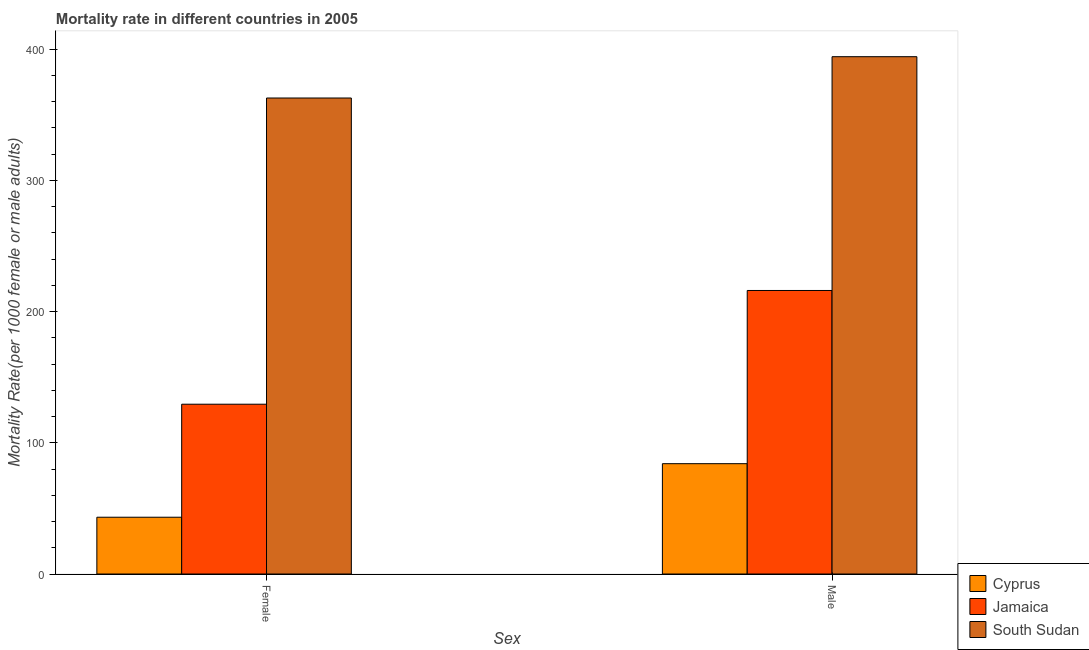How many different coloured bars are there?
Your answer should be compact. 3. How many groups of bars are there?
Provide a short and direct response. 2. Are the number of bars per tick equal to the number of legend labels?
Offer a very short reply. Yes. What is the female mortality rate in Cyprus?
Provide a short and direct response. 43.28. Across all countries, what is the maximum female mortality rate?
Your answer should be compact. 362.8. Across all countries, what is the minimum female mortality rate?
Offer a terse response. 43.28. In which country was the male mortality rate maximum?
Your response must be concise. South Sudan. In which country was the male mortality rate minimum?
Make the answer very short. Cyprus. What is the total male mortality rate in the graph?
Ensure brevity in your answer.  694.47. What is the difference between the female mortality rate in Cyprus and that in South Sudan?
Provide a short and direct response. -319.52. What is the difference between the female mortality rate in Jamaica and the male mortality rate in South Sudan?
Give a very brief answer. -264.87. What is the average female mortality rate per country?
Your response must be concise. 178.5. What is the difference between the male mortality rate and female mortality rate in Jamaica?
Your answer should be very brief. 86.68. What is the ratio of the female mortality rate in Jamaica to that in South Sudan?
Provide a short and direct response. 0.36. Is the female mortality rate in Cyprus less than that in South Sudan?
Offer a terse response. Yes. In how many countries, is the male mortality rate greater than the average male mortality rate taken over all countries?
Offer a terse response. 1. What does the 3rd bar from the left in Male represents?
Provide a short and direct response. South Sudan. What does the 2nd bar from the right in Male represents?
Your response must be concise. Jamaica. How many countries are there in the graph?
Ensure brevity in your answer.  3. What is the difference between two consecutive major ticks on the Y-axis?
Make the answer very short. 100. Does the graph contain any zero values?
Your answer should be very brief. No. Where does the legend appear in the graph?
Offer a terse response. Bottom right. How many legend labels are there?
Your answer should be compact. 3. How are the legend labels stacked?
Keep it short and to the point. Vertical. What is the title of the graph?
Your answer should be very brief. Mortality rate in different countries in 2005. Does "Guyana" appear as one of the legend labels in the graph?
Provide a succinct answer. No. What is the label or title of the X-axis?
Make the answer very short. Sex. What is the label or title of the Y-axis?
Your answer should be very brief. Mortality Rate(per 1000 female or male adults). What is the Mortality Rate(per 1000 female or male adults) in Cyprus in Female?
Keep it short and to the point. 43.28. What is the Mortality Rate(per 1000 female or male adults) in Jamaica in Female?
Provide a succinct answer. 129.42. What is the Mortality Rate(per 1000 female or male adults) of South Sudan in Female?
Give a very brief answer. 362.8. What is the Mortality Rate(per 1000 female or male adults) in Cyprus in Male?
Offer a very short reply. 84.09. What is the Mortality Rate(per 1000 female or male adults) of Jamaica in Male?
Make the answer very short. 216.09. What is the Mortality Rate(per 1000 female or male adults) of South Sudan in Male?
Provide a short and direct response. 394.29. Across all Sex, what is the maximum Mortality Rate(per 1000 female or male adults) of Cyprus?
Ensure brevity in your answer.  84.09. Across all Sex, what is the maximum Mortality Rate(per 1000 female or male adults) of Jamaica?
Your response must be concise. 216.09. Across all Sex, what is the maximum Mortality Rate(per 1000 female or male adults) of South Sudan?
Keep it short and to the point. 394.29. Across all Sex, what is the minimum Mortality Rate(per 1000 female or male adults) of Cyprus?
Ensure brevity in your answer.  43.28. Across all Sex, what is the minimum Mortality Rate(per 1000 female or male adults) in Jamaica?
Your answer should be compact. 129.42. Across all Sex, what is the minimum Mortality Rate(per 1000 female or male adults) of South Sudan?
Keep it short and to the point. 362.8. What is the total Mortality Rate(per 1000 female or male adults) of Cyprus in the graph?
Offer a very short reply. 127.36. What is the total Mortality Rate(per 1000 female or male adults) in Jamaica in the graph?
Provide a short and direct response. 345.51. What is the total Mortality Rate(per 1000 female or male adults) in South Sudan in the graph?
Keep it short and to the point. 757.09. What is the difference between the Mortality Rate(per 1000 female or male adults) of Cyprus in Female and that in Male?
Keep it short and to the point. -40.81. What is the difference between the Mortality Rate(per 1000 female or male adults) in Jamaica in Female and that in Male?
Your response must be concise. -86.68. What is the difference between the Mortality Rate(per 1000 female or male adults) in South Sudan in Female and that in Male?
Ensure brevity in your answer.  -31.49. What is the difference between the Mortality Rate(per 1000 female or male adults) in Cyprus in Female and the Mortality Rate(per 1000 female or male adults) in Jamaica in Male?
Ensure brevity in your answer.  -172.82. What is the difference between the Mortality Rate(per 1000 female or male adults) of Cyprus in Female and the Mortality Rate(per 1000 female or male adults) of South Sudan in Male?
Offer a terse response. -351.01. What is the difference between the Mortality Rate(per 1000 female or male adults) of Jamaica in Female and the Mortality Rate(per 1000 female or male adults) of South Sudan in Male?
Your answer should be compact. -264.87. What is the average Mortality Rate(per 1000 female or male adults) in Cyprus per Sex?
Your answer should be compact. 63.68. What is the average Mortality Rate(per 1000 female or male adults) of Jamaica per Sex?
Offer a very short reply. 172.76. What is the average Mortality Rate(per 1000 female or male adults) in South Sudan per Sex?
Your response must be concise. 378.54. What is the difference between the Mortality Rate(per 1000 female or male adults) in Cyprus and Mortality Rate(per 1000 female or male adults) in Jamaica in Female?
Provide a succinct answer. -86.14. What is the difference between the Mortality Rate(per 1000 female or male adults) of Cyprus and Mortality Rate(per 1000 female or male adults) of South Sudan in Female?
Ensure brevity in your answer.  -319.52. What is the difference between the Mortality Rate(per 1000 female or male adults) in Jamaica and Mortality Rate(per 1000 female or male adults) in South Sudan in Female?
Give a very brief answer. -233.38. What is the difference between the Mortality Rate(per 1000 female or male adults) of Cyprus and Mortality Rate(per 1000 female or male adults) of Jamaica in Male?
Provide a short and direct response. -132.01. What is the difference between the Mortality Rate(per 1000 female or male adults) of Cyprus and Mortality Rate(per 1000 female or male adults) of South Sudan in Male?
Your answer should be compact. -310.2. What is the difference between the Mortality Rate(per 1000 female or male adults) of Jamaica and Mortality Rate(per 1000 female or male adults) of South Sudan in Male?
Offer a very short reply. -178.19. What is the ratio of the Mortality Rate(per 1000 female or male adults) of Cyprus in Female to that in Male?
Your response must be concise. 0.51. What is the ratio of the Mortality Rate(per 1000 female or male adults) in Jamaica in Female to that in Male?
Offer a very short reply. 0.6. What is the ratio of the Mortality Rate(per 1000 female or male adults) of South Sudan in Female to that in Male?
Give a very brief answer. 0.92. What is the difference between the highest and the second highest Mortality Rate(per 1000 female or male adults) in Cyprus?
Provide a succinct answer. 40.81. What is the difference between the highest and the second highest Mortality Rate(per 1000 female or male adults) of Jamaica?
Provide a short and direct response. 86.68. What is the difference between the highest and the second highest Mortality Rate(per 1000 female or male adults) of South Sudan?
Offer a very short reply. 31.49. What is the difference between the highest and the lowest Mortality Rate(per 1000 female or male adults) in Cyprus?
Make the answer very short. 40.81. What is the difference between the highest and the lowest Mortality Rate(per 1000 female or male adults) in Jamaica?
Ensure brevity in your answer.  86.68. What is the difference between the highest and the lowest Mortality Rate(per 1000 female or male adults) in South Sudan?
Provide a succinct answer. 31.49. 